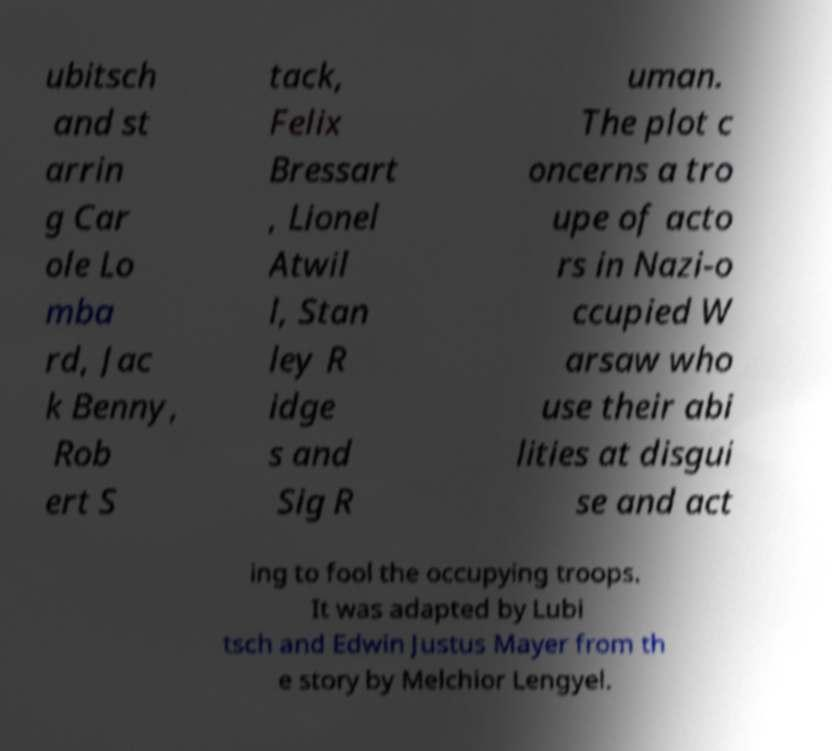Can you accurately transcribe the text from the provided image for me? ubitsch and st arrin g Car ole Lo mba rd, Jac k Benny, Rob ert S tack, Felix Bressart , Lionel Atwil l, Stan ley R idge s and Sig R uman. The plot c oncerns a tro upe of acto rs in Nazi-o ccupied W arsaw who use their abi lities at disgui se and act ing to fool the occupying troops. It was adapted by Lubi tsch and Edwin Justus Mayer from th e story by Melchior Lengyel. 